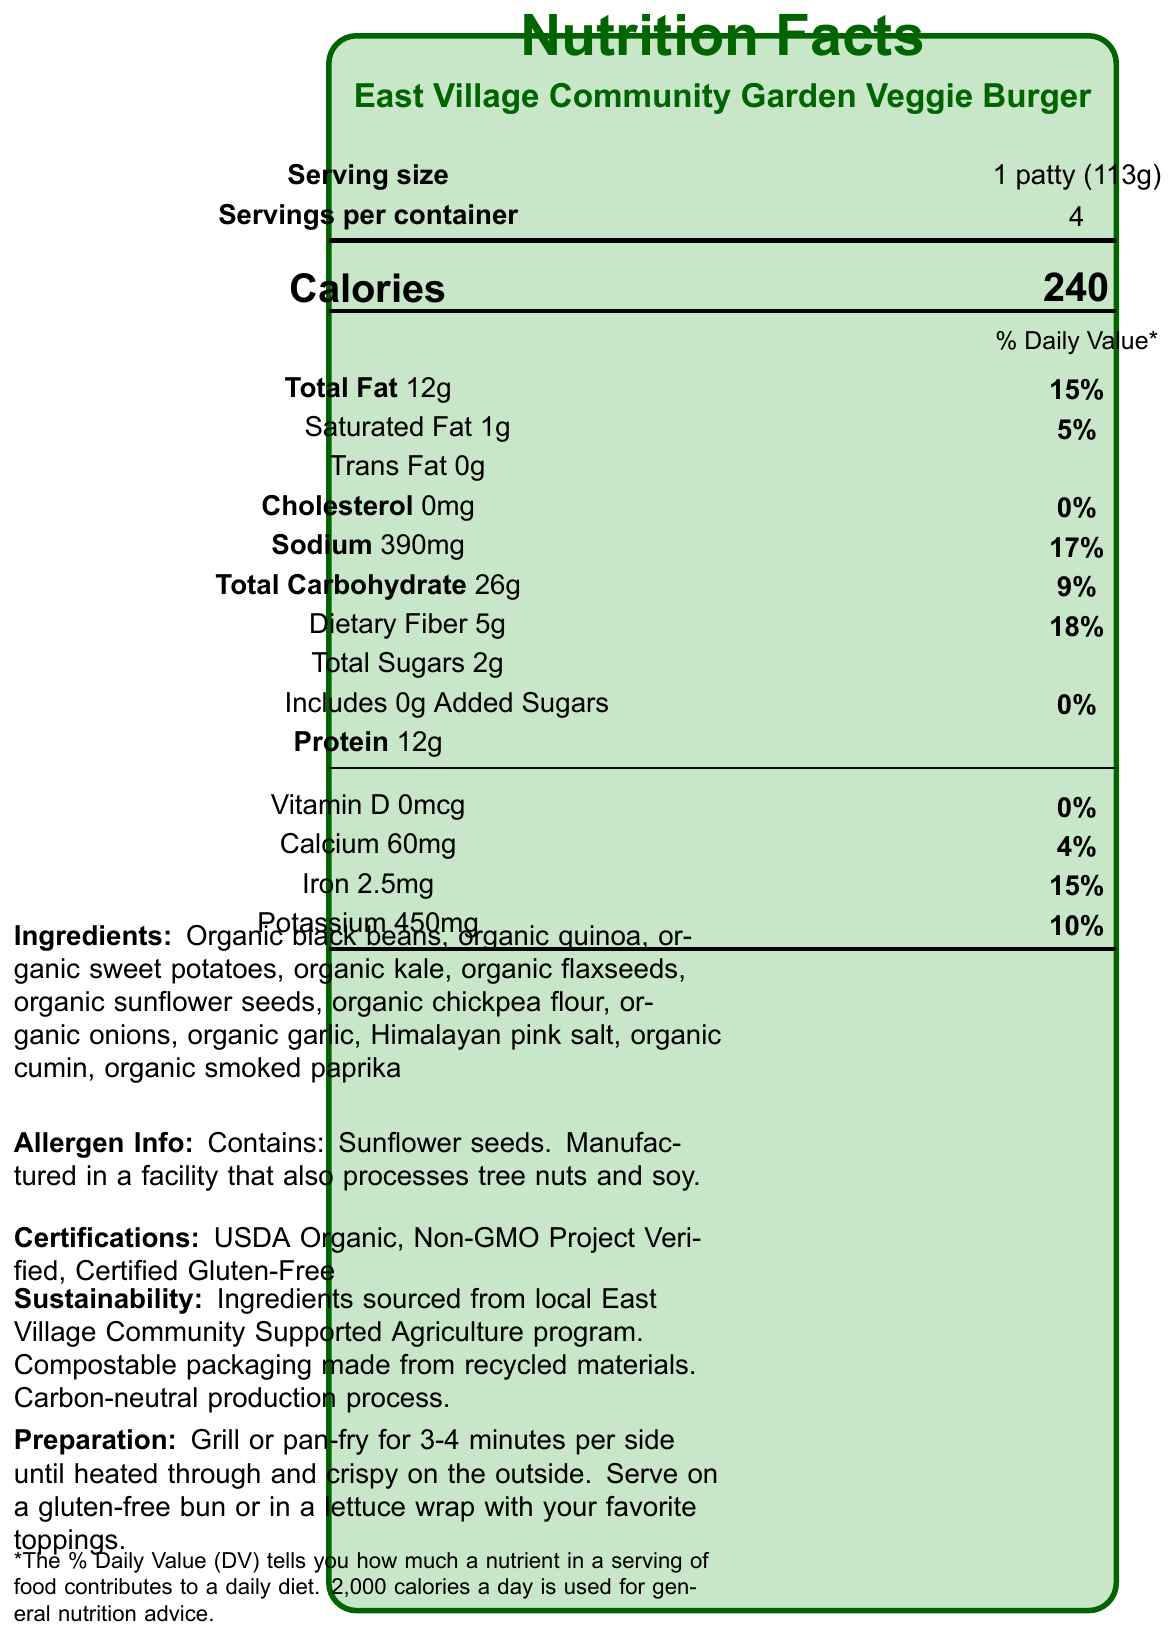what is the serving size per patty? The document states the serving size as 1 patty (113g).
Answer: 1 patty (113g) how many calories are in one serving of this veggie burger? The document lists the calorie content as 240 per serving.
Answer: 240 what is the total fat content per serving? The total fat content per serving is listed as 12g.
Answer: 12g which allergen does this veggie burger contain? The allergen information section states that it contains sunflower seeds.
Answer: Sunflower seeds what is the daily value percentage for dietary fiber? The daily value percentage for dietary fiber is given as 18%.
Answer: 18% how many grams of added sugars are there in this veggie burger? The document mentions that the veggie burger includes 0g of added sugars.
Answer: 0g how many servings are there in a container? It states there are 4 servings per container.
Answer: 4 what is the amount of protein per serving in grams? The amount of protein per serving is listed as 12g.
Answer: 12g the veggie burger has nutrients like calcium and iron. what are their daily value percentages? The document states the daily value percentages as 4% for calcium and 15% for iron.
Answer: Calcium: 4%, Iron: 15% which of the following is a key sustainability feature of the product? A. Imported ingredients B. Plastic packaging C. Compostable packaging D. Energy-intensive production process One key sustainability feature mentioned is compostable packaging made from recycled materials.
Answer: C. Compostable packaging which certification does this veggie burger have? A. Organic Certified B. Halal Certified C. Fair Trade Certified D. Non-GMO Project Verified The certifications include USDA Organic and Non-GMO Project Verified, but not Fair Trade or Halal.
Answer: D. Non-GMO Project Verified is the preparation method for this veggie burger grilling? Yes/No The preparation instructions include grilling or pan-frying the patty.
Answer: Yes describe the overall nutritional and sustainability characteristics of the East Village Community Garden Veggie Burger. The veggie burger offers all plant-based, natural ingredients with a strong focus on sustainability, including compostable packaging and locally sourced ingredients.
Answer: The East Village Community Garden Veggie Burger is a plant-based, gluten-free product with 240 calories per serving. It contains 12g of protein, 12g of total fat, and 5g of dietary fiber. It has no cholesterol and very low saturated fat. The burger includes natural ingredients like organic black beans and quinoa, and it is certified organic, non-GMO, and gluten-free. Importantly, it emphasizes sustainability with compostable packaging, carbon-neutral production, and locally sourced ingredients. how many grams of sodium are in one patty? The sodium content per patty is 390mg.
Answer: 390mg what percentage of the daily value does saturated fat contribute? The saturated fat contributes 5% to the daily value.
Answer: 5% what type of salt is used in the ingredients? The ingredients list includes Himalayan pink salt.
Answer: Himalayan pink salt how much vitamin D does the veggie burger contain? The document states that the amount of vitamin D is 0mcg.
Answer: 0mcg what flavor enhancer does this product contain? The document does not mention any specific flavor enhancers.
Answer: Cannot be determined 